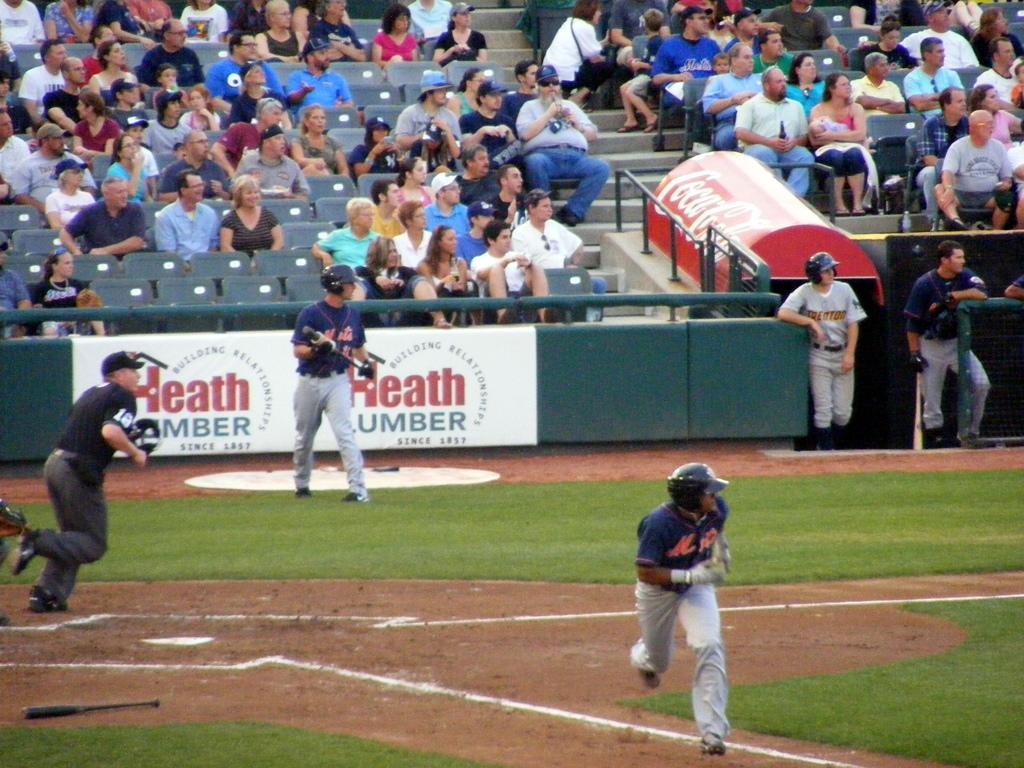<image>
Relay a brief, clear account of the picture shown. Baseball players play in front of signs for Heath Lumber, who have been in business since 1857. 